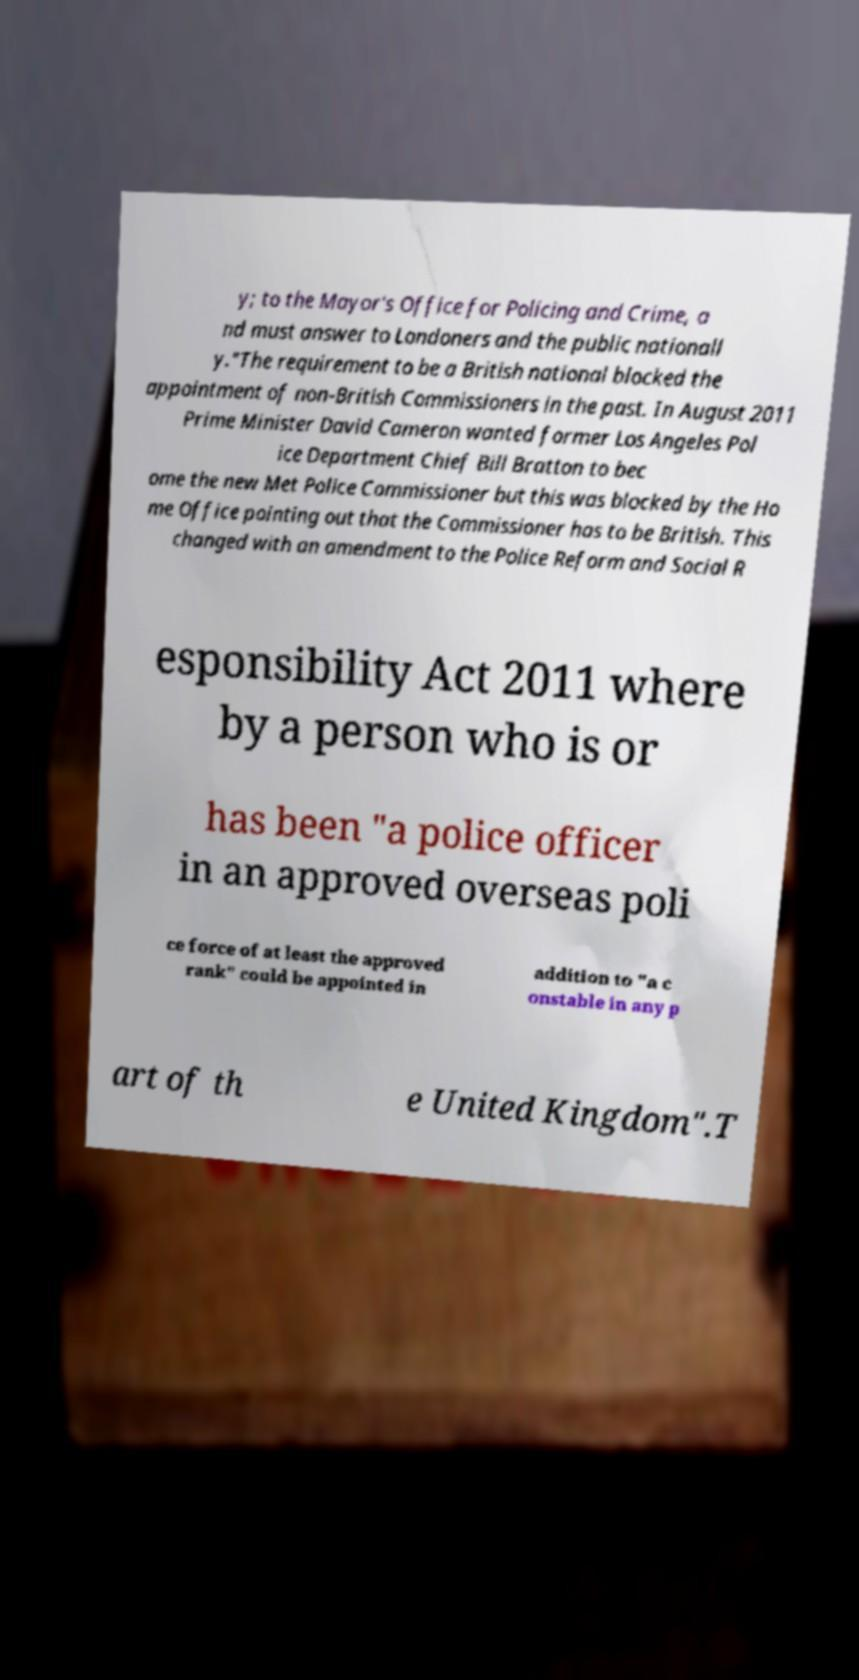Please read and relay the text visible in this image. What does it say? y; to the Mayor's Office for Policing and Crime, a nd must answer to Londoners and the public nationall y."The requirement to be a British national blocked the appointment of non-British Commissioners in the past. In August 2011 Prime Minister David Cameron wanted former Los Angeles Pol ice Department Chief Bill Bratton to bec ome the new Met Police Commissioner but this was blocked by the Ho me Office pointing out that the Commissioner has to be British. This changed with an amendment to the Police Reform and Social R esponsibility Act 2011 where by a person who is or has been "a police officer in an approved overseas poli ce force of at least the approved rank" could be appointed in addition to "a c onstable in any p art of th e United Kingdom".T 